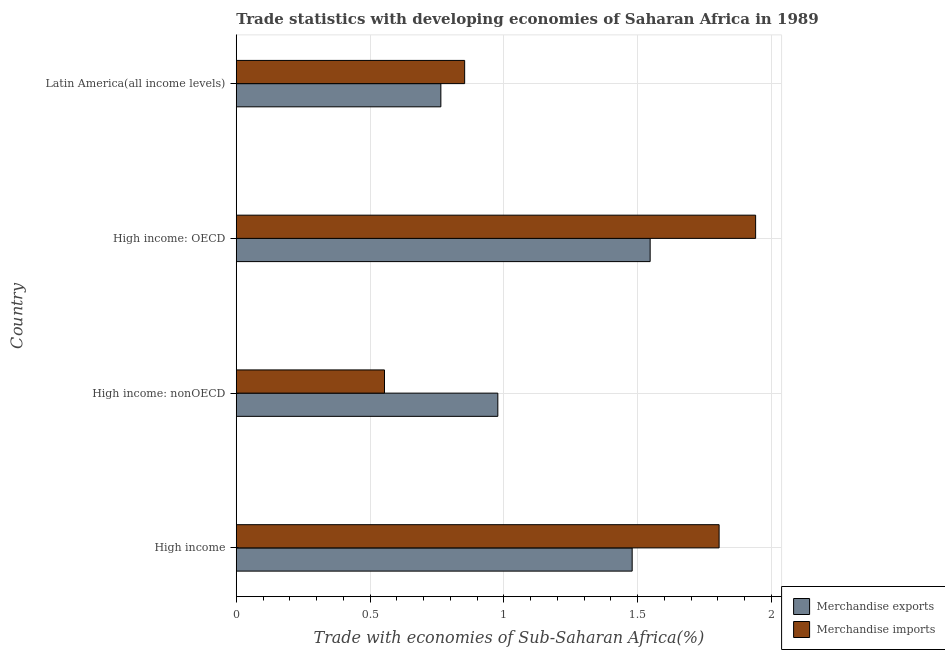Are the number of bars on each tick of the Y-axis equal?
Your answer should be compact. Yes. How many bars are there on the 2nd tick from the top?
Keep it short and to the point. 2. What is the label of the 3rd group of bars from the top?
Keep it short and to the point. High income: nonOECD. In how many cases, is the number of bars for a given country not equal to the number of legend labels?
Keep it short and to the point. 0. What is the merchandise exports in High income: OECD?
Offer a very short reply. 1.55. Across all countries, what is the maximum merchandise imports?
Give a very brief answer. 1.94. Across all countries, what is the minimum merchandise imports?
Offer a terse response. 0.55. In which country was the merchandise imports maximum?
Ensure brevity in your answer.  High income: OECD. In which country was the merchandise imports minimum?
Provide a short and direct response. High income: nonOECD. What is the total merchandise exports in the graph?
Offer a very short reply. 4.77. What is the difference between the merchandise imports in High income: OECD and that in High income: nonOECD?
Your answer should be compact. 1.39. What is the difference between the merchandise imports in High income and the merchandise exports in Latin America(all income levels)?
Make the answer very short. 1.04. What is the average merchandise imports per country?
Your response must be concise. 1.29. What is the difference between the merchandise imports and merchandise exports in High income: OECD?
Your answer should be compact. 0.39. What is the ratio of the merchandise imports in High income: nonOECD to that in Latin America(all income levels)?
Your response must be concise. 0.65. What is the difference between the highest and the second highest merchandise imports?
Give a very brief answer. 0.14. What is the difference between the highest and the lowest merchandise exports?
Ensure brevity in your answer.  0.78. In how many countries, is the merchandise imports greater than the average merchandise imports taken over all countries?
Ensure brevity in your answer.  2. Is the sum of the merchandise exports in High income and Latin America(all income levels) greater than the maximum merchandise imports across all countries?
Ensure brevity in your answer.  Yes. Are all the bars in the graph horizontal?
Your response must be concise. Yes. What is the difference between two consecutive major ticks on the X-axis?
Offer a very short reply. 0.5. Does the graph contain grids?
Provide a short and direct response. Yes. How are the legend labels stacked?
Offer a very short reply. Vertical. What is the title of the graph?
Give a very brief answer. Trade statistics with developing economies of Saharan Africa in 1989. What is the label or title of the X-axis?
Keep it short and to the point. Trade with economies of Sub-Saharan Africa(%). What is the Trade with economies of Sub-Saharan Africa(%) of Merchandise exports in High income?
Offer a terse response. 1.48. What is the Trade with economies of Sub-Saharan Africa(%) in Merchandise imports in High income?
Offer a terse response. 1.8. What is the Trade with economies of Sub-Saharan Africa(%) in Merchandise exports in High income: nonOECD?
Give a very brief answer. 0.98. What is the Trade with economies of Sub-Saharan Africa(%) in Merchandise imports in High income: nonOECD?
Give a very brief answer. 0.55. What is the Trade with economies of Sub-Saharan Africa(%) in Merchandise exports in High income: OECD?
Give a very brief answer. 1.55. What is the Trade with economies of Sub-Saharan Africa(%) in Merchandise imports in High income: OECD?
Give a very brief answer. 1.94. What is the Trade with economies of Sub-Saharan Africa(%) of Merchandise exports in Latin America(all income levels)?
Your response must be concise. 0.76. What is the Trade with economies of Sub-Saharan Africa(%) of Merchandise imports in Latin America(all income levels)?
Keep it short and to the point. 0.85. Across all countries, what is the maximum Trade with economies of Sub-Saharan Africa(%) in Merchandise exports?
Your answer should be very brief. 1.55. Across all countries, what is the maximum Trade with economies of Sub-Saharan Africa(%) of Merchandise imports?
Offer a very short reply. 1.94. Across all countries, what is the minimum Trade with economies of Sub-Saharan Africa(%) in Merchandise exports?
Ensure brevity in your answer.  0.76. Across all countries, what is the minimum Trade with economies of Sub-Saharan Africa(%) of Merchandise imports?
Give a very brief answer. 0.55. What is the total Trade with economies of Sub-Saharan Africa(%) in Merchandise exports in the graph?
Give a very brief answer. 4.77. What is the total Trade with economies of Sub-Saharan Africa(%) of Merchandise imports in the graph?
Your answer should be very brief. 5.15. What is the difference between the Trade with economies of Sub-Saharan Africa(%) in Merchandise exports in High income and that in High income: nonOECD?
Your answer should be very brief. 0.5. What is the difference between the Trade with economies of Sub-Saharan Africa(%) of Merchandise imports in High income and that in High income: nonOECD?
Your answer should be very brief. 1.25. What is the difference between the Trade with economies of Sub-Saharan Africa(%) of Merchandise exports in High income and that in High income: OECD?
Provide a short and direct response. -0.07. What is the difference between the Trade with economies of Sub-Saharan Africa(%) of Merchandise imports in High income and that in High income: OECD?
Offer a very short reply. -0.14. What is the difference between the Trade with economies of Sub-Saharan Africa(%) in Merchandise exports in High income and that in Latin America(all income levels)?
Provide a succinct answer. 0.71. What is the difference between the Trade with economies of Sub-Saharan Africa(%) in Merchandise imports in High income and that in Latin America(all income levels)?
Give a very brief answer. 0.95. What is the difference between the Trade with economies of Sub-Saharan Africa(%) in Merchandise exports in High income: nonOECD and that in High income: OECD?
Make the answer very short. -0.57. What is the difference between the Trade with economies of Sub-Saharan Africa(%) in Merchandise imports in High income: nonOECD and that in High income: OECD?
Your answer should be compact. -1.39. What is the difference between the Trade with economies of Sub-Saharan Africa(%) in Merchandise exports in High income: nonOECD and that in Latin America(all income levels)?
Keep it short and to the point. 0.21. What is the difference between the Trade with economies of Sub-Saharan Africa(%) in Merchandise imports in High income: nonOECD and that in Latin America(all income levels)?
Your answer should be compact. -0.3. What is the difference between the Trade with economies of Sub-Saharan Africa(%) in Merchandise exports in High income: OECD and that in Latin America(all income levels)?
Give a very brief answer. 0.78. What is the difference between the Trade with economies of Sub-Saharan Africa(%) in Merchandise imports in High income: OECD and that in Latin America(all income levels)?
Offer a very short reply. 1.09. What is the difference between the Trade with economies of Sub-Saharan Africa(%) in Merchandise exports in High income and the Trade with economies of Sub-Saharan Africa(%) in Merchandise imports in High income: nonOECD?
Make the answer very short. 0.93. What is the difference between the Trade with economies of Sub-Saharan Africa(%) in Merchandise exports in High income and the Trade with economies of Sub-Saharan Africa(%) in Merchandise imports in High income: OECD?
Your answer should be compact. -0.46. What is the difference between the Trade with economies of Sub-Saharan Africa(%) of Merchandise exports in High income and the Trade with economies of Sub-Saharan Africa(%) of Merchandise imports in Latin America(all income levels)?
Provide a short and direct response. 0.63. What is the difference between the Trade with economies of Sub-Saharan Africa(%) of Merchandise exports in High income: nonOECD and the Trade with economies of Sub-Saharan Africa(%) of Merchandise imports in High income: OECD?
Ensure brevity in your answer.  -0.96. What is the difference between the Trade with economies of Sub-Saharan Africa(%) of Merchandise exports in High income: nonOECD and the Trade with economies of Sub-Saharan Africa(%) of Merchandise imports in Latin America(all income levels)?
Offer a very short reply. 0.12. What is the difference between the Trade with economies of Sub-Saharan Africa(%) in Merchandise exports in High income: OECD and the Trade with economies of Sub-Saharan Africa(%) in Merchandise imports in Latin America(all income levels)?
Your response must be concise. 0.69. What is the average Trade with economies of Sub-Saharan Africa(%) of Merchandise exports per country?
Provide a short and direct response. 1.19. What is the average Trade with economies of Sub-Saharan Africa(%) in Merchandise imports per country?
Ensure brevity in your answer.  1.29. What is the difference between the Trade with economies of Sub-Saharan Africa(%) of Merchandise exports and Trade with economies of Sub-Saharan Africa(%) of Merchandise imports in High income?
Offer a very short reply. -0.32. What is the difference between the Trade with economies of Sub-Saharan Africa(%) in Merchandise exports and Trade with economies of Sub-Saharan Africa(%) in Merchandise imports in High income: nonOECD?
Keep it short and to the point. 0.42. What is the difference between the Trade with economies of Sub-Saharan Africa(%) in Merchandise exports and Trade with economies of Sub-Saharan Africa(%) in Merchandise imports in High income: OECD?
Give a very brief answer. -0.39. What is the difference between the Trade with economies of Sub-Saharan Africa(%) in Merchandise exports and Trade with economies of Sub-Saharan Africa(%) in Merchandise imports in Latin America(all income levels)?
Keep it short and to the point. -0.09. What is the ratio of the Trade with economies of Sub-Saharan Africa(%) in Merchandise exports in High income to that in High income: nonOECD?
Your answer should be very brief. 1.51. What is the ratio of the Trade with economies of Sub-Saharan Africa(%) in Merchandise imports in High income to that in High income: nonOECD?
Make the answer very short. 3.26. What is the ratio of the Trade with economies of Sub-Saharan Africa(%) in Merchandise exports in High income to that in High income: OECD?
Give a very brief answer. 0.96. What is the ratio of the Trade with economies of Sub-Saharan Africa(%) in Merchandise imports in High income to that in High income: OECD?
Ensure brevity in your answer.  0.93. What is the ratio of the Trade with economies of Sub-Saharan Africa(%) in Merchandise exports in High income to that in Latin America(all income levels)?
Make the answer very short. 1.94. What is the ratio of the Trade with economies of Sub-Saharan Africa(%) in Merchandise imports in High income to that in Latin America(all income levels)?
Keep it short and to the point. 2.11. What is the ratio of the Trade with economies of Sub-Saharan Africa(%) of Merchandise exports in High income: nonOECD to that in High income: OECD?
Your answer should be very brief. 0.63. What is the ratio of the Trade with economies of Sub-Saharan Africa(%) of Merchandise imports in High income: nonOECD to that in High income: OECD?
Offer a terse response. 0.29. What is the ratio of the Trade with economies of Sub-Saharan Africa(%) of Merchandise exports in High income: nonOECD to that in Latin America(all income levels)?
Offer a very short reply. 1.28. What is the ratio of the Trade with economies of Sub-Saharan Africa(%) in Merchandise imports in High income: nonOECD to that in Latin America(all income levels)?
Provide a short and direct response. 0.65. What is the ratio of the Trade with economies of Sub-Saharan Africa(%) in Merchandise exports in High income: OECD to that in Latin America(all income levels)?
Keep it short and to the point. 2.02. What is the ratio of the Trade with economies of Sub-Saharan Africa(%) of Merchandise imports in High income: OECD to that in Latin America(all income levels)?
Provide a succinct answer. 2.27. What is the difference between the highest and the second highest Trade with economies of Sub-Saharan Africa(%) of Merchandise exports?
Offer a terse response. 0.07. What is the difference between the highest and the second highest Trade with economies of Sub-Saharan Africa(%) in Merchandise imports?
Provide a short and direct response. 0.14. What is the difference between the highest and the lowest Trade with economies of Sub-Saharan Africa(%) in Merchandise exports?
Provide a succinct answer. 0.78. What is the difference between the highest and the lowest Trade with economies of Sub-Saharan Africa(%) of Merchandise imports?
Your response must be concise. 1.39. 